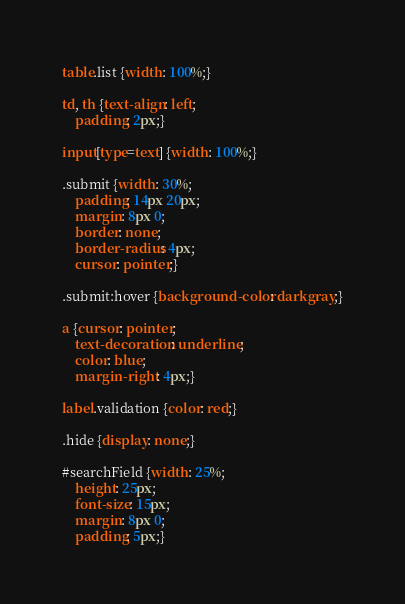<code> <loc_0><loc_0><loc_500><loc_500><_CSS_>table.list {width: 100%;}

td, th {text-align: left;
    padding: 2px;}

input[type=text] {width: 100%;}

.submit {width: 30%;
    padding: 14px 20px;
    margin: 8px 0;
    border: none;
    border-radius: 4px;
    cursor: pointer;}

.submit:hover {background-color: darkgray;}

a {cursor: pointer;
    text-decoration: underline;
    color: blue;
    margin-right: 4px;}

label.validation {color: red;}

.hide {display: none;}

#searchField {width: 25%;
    height: 25px;
    font-size: 15px;
    margin: 8px 0;
    padding: 5px;}</code> 